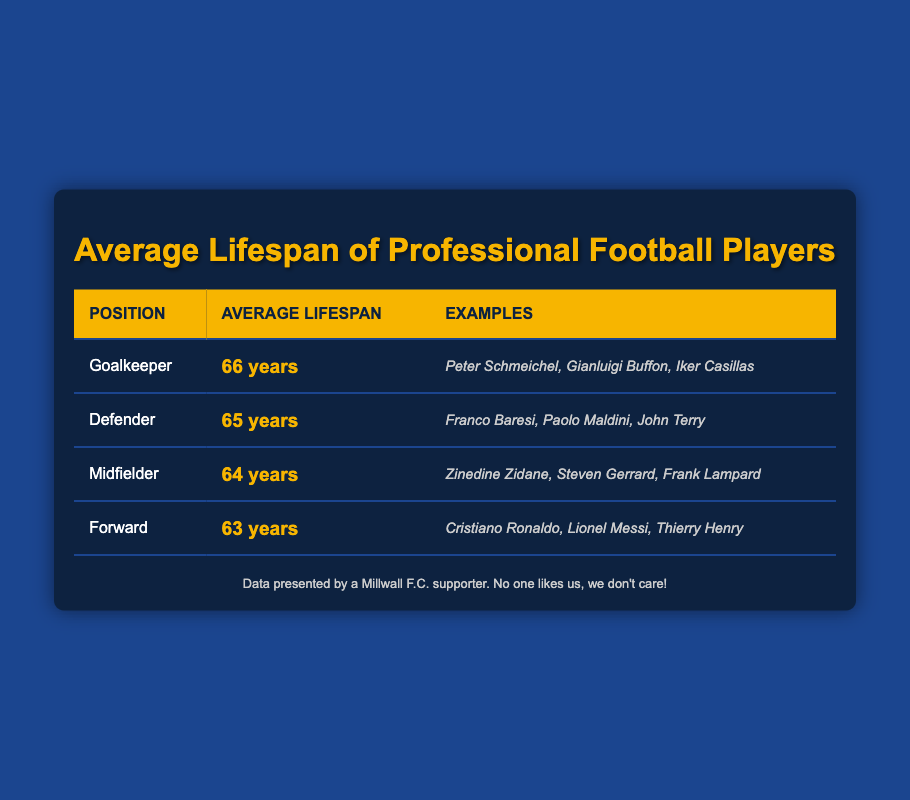What is the average lifespan of a goalkeeper? The table lists the average lifespan of a goalkeeper as 66 years.
Answer: 66 years Which position has the shortest average lifespan? By comparing the average lifespans listed in the table, the forward position is identified with the shortest average lifespan of 63 years.
Answer: Forward What is the average lifespan of defenders compared to midfielders? According to the table, defenders have an average lifespan of 65 years, while midfielders have an average lifespan of 64 years. Therefore, defenders live on average 1 year longer than midfielders.
Answer: Defenders live 1 year longer than midfielders Are there any positions that have the same lifespan? The table shows that there are no positions listed with the same average lifespan. Each position has a distinct lifespan.
Answer: No If you average the lifespans of all positions, what is the result? The average lifespan can be calculated by adding the lifespans: 66 (goalkeeper) + 65 (defender) + 64 (midfielder) + 63 (forward) = 258 years. Dividing this total by 4 positions gives an average lifespan of 64.5 years.
Answer: 64.5 years Which player is an example of a midfielder? The table provides Zinedine Zidane, Steven Gerrard, and Frank Lampard as examples of midfielders. Any of these names can be given as an example.
Answer: Zinedine Zidane What is the difference in average lifespan between goalkeepers and forwards? The average lifespan for goalkeepers is 66 years, and for forwards, it is 63 years. The difference is calculated as 66 - 63 = 3 years.
Answer: 3 years Is it true that all defenders have a lifespan that exceeds 64 years? The table shows that defenders have an average lifespan of 65 years, which does exceed 64 years. Therefore, the statement is true.
Answer: Yes What position has an average lifespan that is closer to 64 years? The lifespans are as follows: goalkeepers (66), defenders (65), midfielders (64), forwards (63). The defender at 65 years is closest to 64 years, followed by midfielders at 64 years.
Answer: Defender 